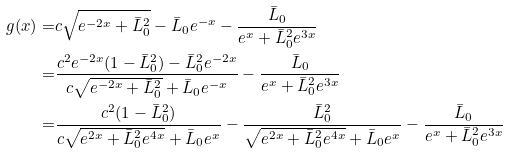Convert formula to latex. <formula><loc_0><loc_0><loc_500><loc_500>g ( x ) = & c \sqrt { e ^ { - 2 x } + \bar { L } _ { 0 } ^ { 2 } } - \bar { L } _ { 0 } e ^ { - x } - \frac { \bar { L } _ { 0 } } { e ^ { x } + \bar { L } _ { 0 } ^ { 2 } e ^ { 3 x } } \\ = & \frac { c ^ { 2 } e ^ { - 2 x } ( 1 - \bar { L } _ { 0 } ^ { 2 } ) - \bar { L } _ { 0 } ^ { 2 } e ^ { - 2 x } } { c \sqrt { e ^ { - 2 x } + \bar { L } _ { 0 } ^ { 2 } } + \bar { L } _ { 0 } e ^ { - x } } - \frac { \bar { L } _ { 0 } } { e ^ { x } + \bar { L } _ { 0 } ^ { 2 } e ^ { 3 x } } \\ = & \frac { c ^ { 2 } ( 1 - \bar { L } _ { 0 } ^ { 2 } ) } { c \sqrt { e ^ { 2 x } + \bar { L } _ { 0 } ^ { 2 } e ^ { 4 x } } + \bar { L } _ { 0 } e ^ { x } } - \frac { \bar { L } _ { 0 } ^ { 2 } } { \sqrt { e ^ { 2 x } + \bar { L } _ { 0 } ^ { 2 } e ^ { 4 x } } + \bar { L } _ { 0 } e ^ { x } } - \frac { \bar { L } _ { 0 } } { e ^ { x } + \bar { L } _ { 0 } ^ { 2 } e ^ { 3 x } }</formula> 